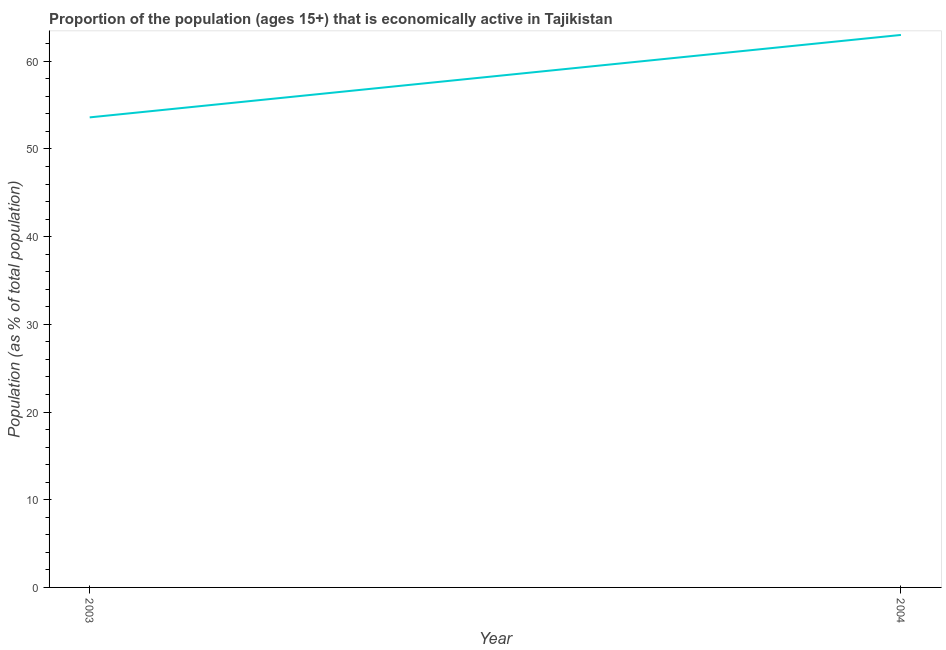What is the percentage of economically active population in 2003?
Provide a short and direct response. 53.6. Across all years, what is the maximum percentage of economically active population?
Keep it short and to the point. 63. Across all years, what is the minimum percentage of economically active population?
Offer a terse response. 53.6. What is the sum of the percentage of economically active population?
Offer a very short reply. 116.6. What is the difference between the percentage of economically active population in 2003 and 2004?
Provide a succinct answer. -9.4. What is the average percentage of economically active population per year?
Offer a terse response. 58.3. What is the median percentage of economically active population?
Ensure brevity in your answer.  58.3. Do a majority of the years between 2004 and 2003 (inclusive) have percentage of economically active population greater than 14 %?
Offer a terse response. No. What is the ratio of the percentage of economically active population in 2003 to that in 2004?
Provide a succinct answer. 0.85. How many lines are there?
Ensure brevity in your answer.  1. What is the difference between two consecutive major ticks on the Y-axis?
Give a very brief answer. 10. Does the graph contain any zero values?
Give a very brief answer. No. Does the graph contain grids?
Give a very brief answer. No. What is the title of the graph?
Provide a succinct answer. Proportion of the population (ages 15+) that is economically active in Tajikistan. What is the label or title of the X-axis?
Make the answer very short. Year. What is the label or title of the Y-axis?
Give a very brief answer. Population (as % of total population). What is the Population (as % of total population) in 2003?
Provide a short and direct response. 53.6. What is the Population (as % of total population) in 2004?
Offer a terse response. 63. What is the ratio of the Population (as % of total population) in 2003 to that in 2004?
Offer a very short reply. 0.85. 